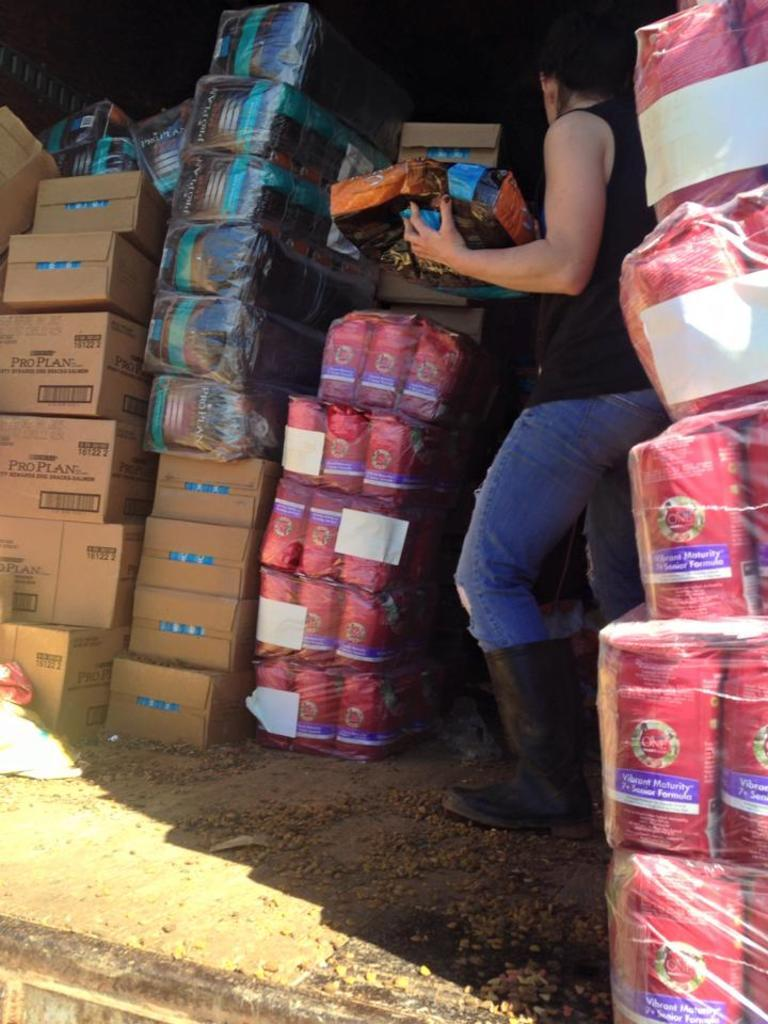What is the main subject of the image? There is a person in the image. Can you describe the person's position in the image? The person is standing in the middle of parcel boxes. What type of shoe is the duck wearing in the image? There is no duck or shoe present in the image; it features a person standing among parcel boxes. 